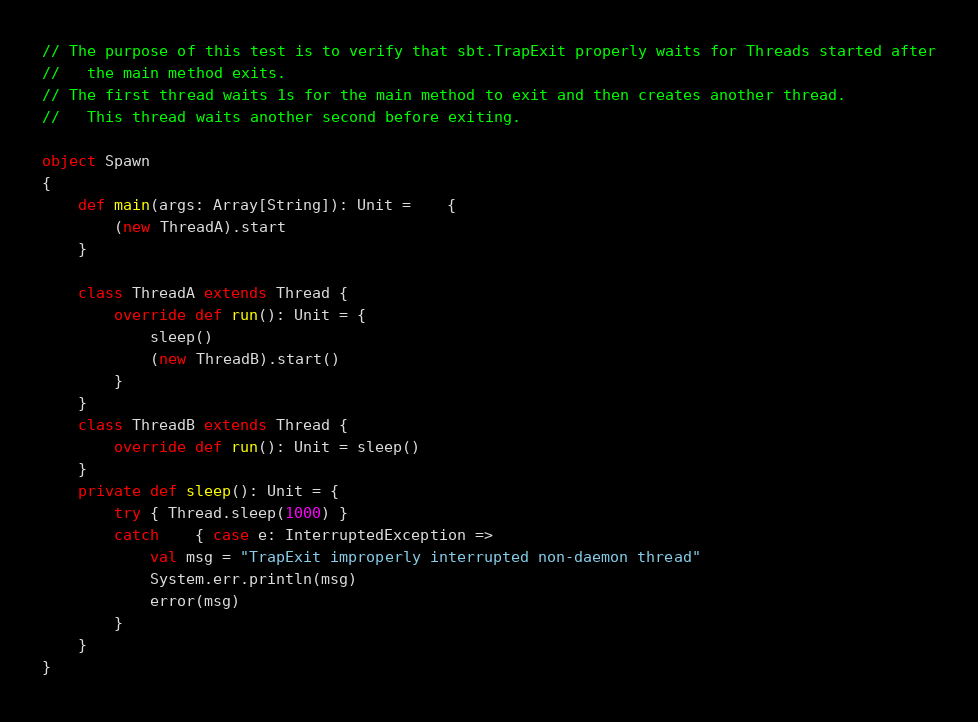<code> <loc_0><loc_0><loc_500><loc_500><_Scala_>// The purpose of this test is to verify that sbt.TrapExit properly waits for Threads started after
//   the main method exits.
// The first thread waits 1s for the main method to exit and then creates another thread.
//   This thread waits another second before exiting.

object Spawn
{
	def main(args: Array[String]): Unit =	{
		(new ThreadA).start
	}

	class ThreadA extends Thread {
		override def run(): Unit = {
			sleep()
			(new ThreadB).start()
		}
	}
	class ThreadB extends Thread {
		override def run(): Unit = sleep()
	}
	private def sleep(): Unit = {
		try { Thread.sleep(1000) }
		catch	{ case e: InterruptedException =>
			val msg = "TrapExit improperly interrupted non-daemon thread"
			System.err.println(msg)
			error(msg)
		}
	}
}
</code> 